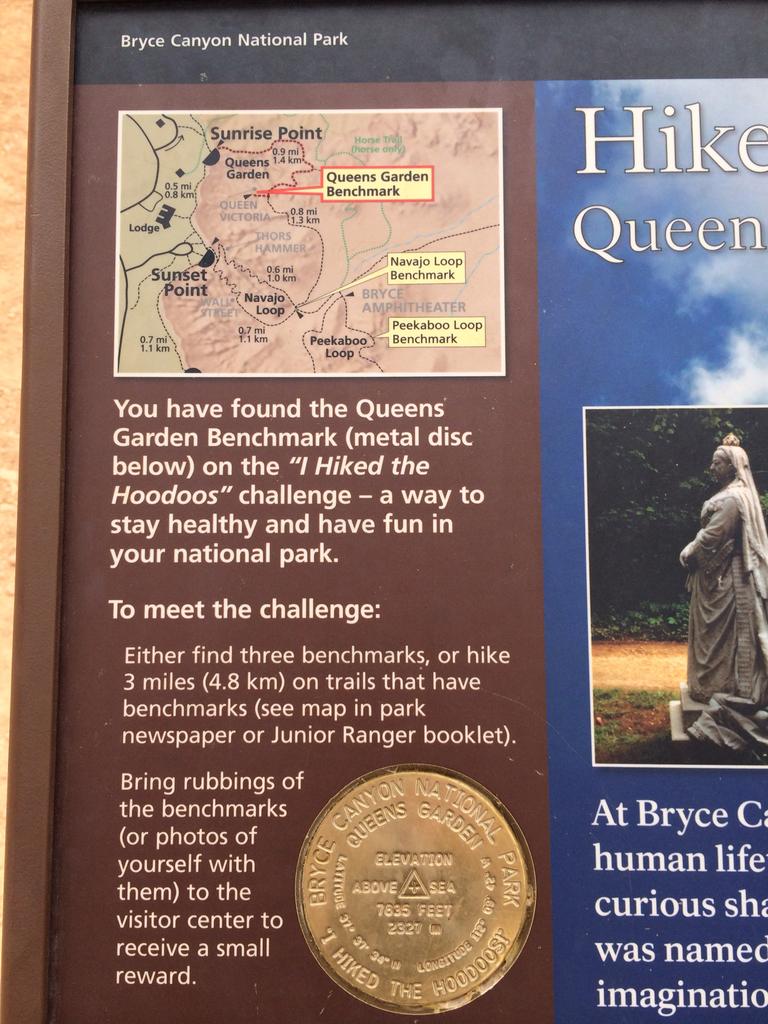Is this about walking far distances?
Give a very brief answer. Yes. What is the 2nd word in the top left hand area of the photo?
Your response must be concise. Canyon. 